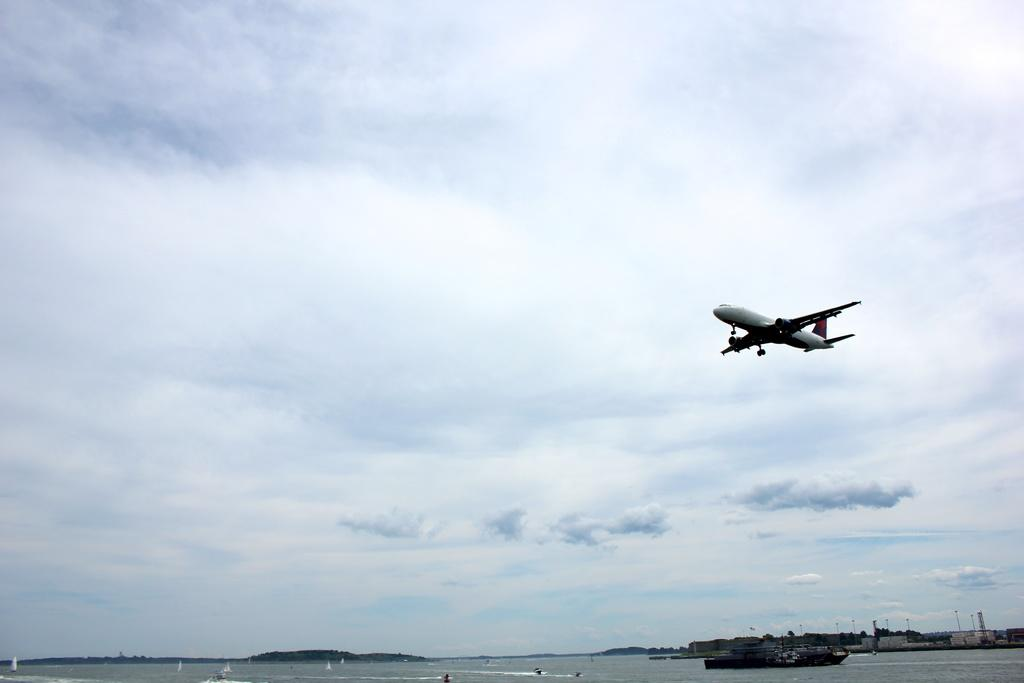What is floating on the water in the image? There is a boat floating on the water in the image. What type of vegetation can be seen in the image? Trees are visible in the image. What structures are present in the image? There are towers in the image. What is flying in the air in the image? An airplane is flying in the air in the image. What is the condition of the sky in the background? The sky in the background is cloudy. Can you tell me what question the boat is asking in the image? There is no indication in the image that the boat is asking a question. Is the grandmother smiling in the image? There is no grandmother present in the image. 